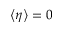<formula> <loc_0><loc_0><loc_500><loc_500>\left < \eta \right > = 0</formula> 